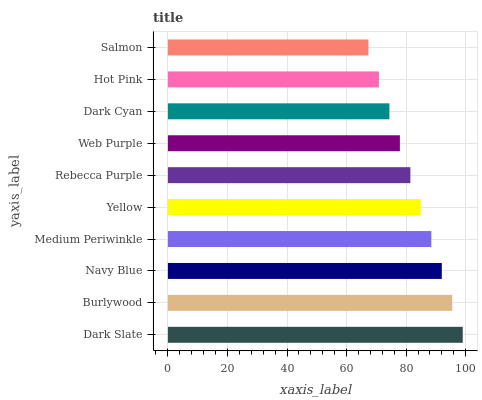Is Salmon the minimum?
Answer yes or no. Yes. Is Dark Slate the maximum?
Answer yes or no. Yes. Is Burlywood the minimum?
Answer yes or no. No. Is Burlywood the maximum?
Answer yes or no. No. Is Dark Slate greater than Burlywood?
Answer yes or no. Yes. Is Burlywood less than Dark Slate?
Answer yes or no. Yes. Is Burlywood greater than Dark Slate?
Answer yes or no. No. Is Dark Slate less than Burlywood?
Answer yes or no. No. Is Yellow the high median?
Answer yes or no. Yes. Is Rebecca Purple the low median?
Answer yes or no. Yes. Is Web Purple the high median?
Answer yes or no. No. Is Medium Periwinkle the low median?
Answer yes or no. No. 